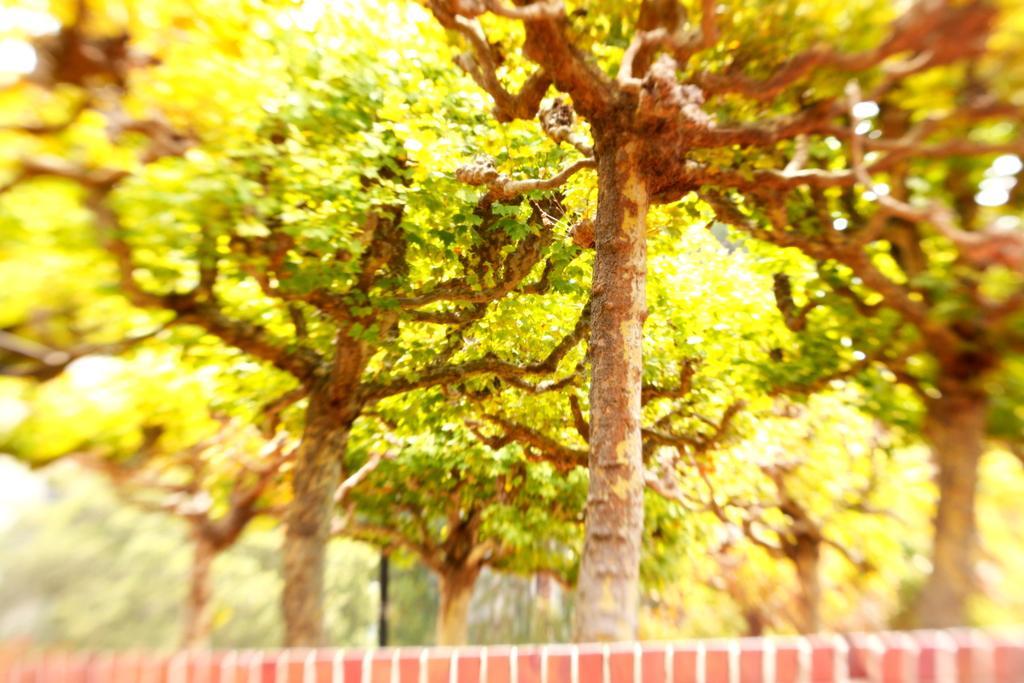Can you describe this image briefly? This picture is blurry and we can see trees. 